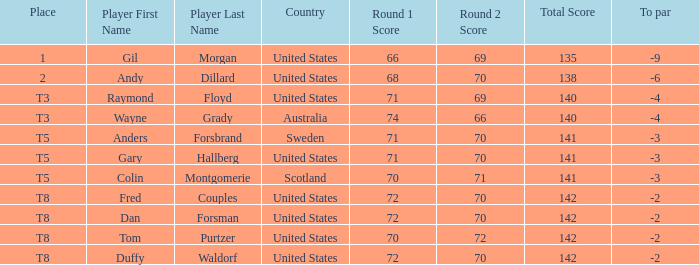What is the t8 position player? Fred Couples, Dan Forsman, Tom Purtzer, Duffy Waldorf. 